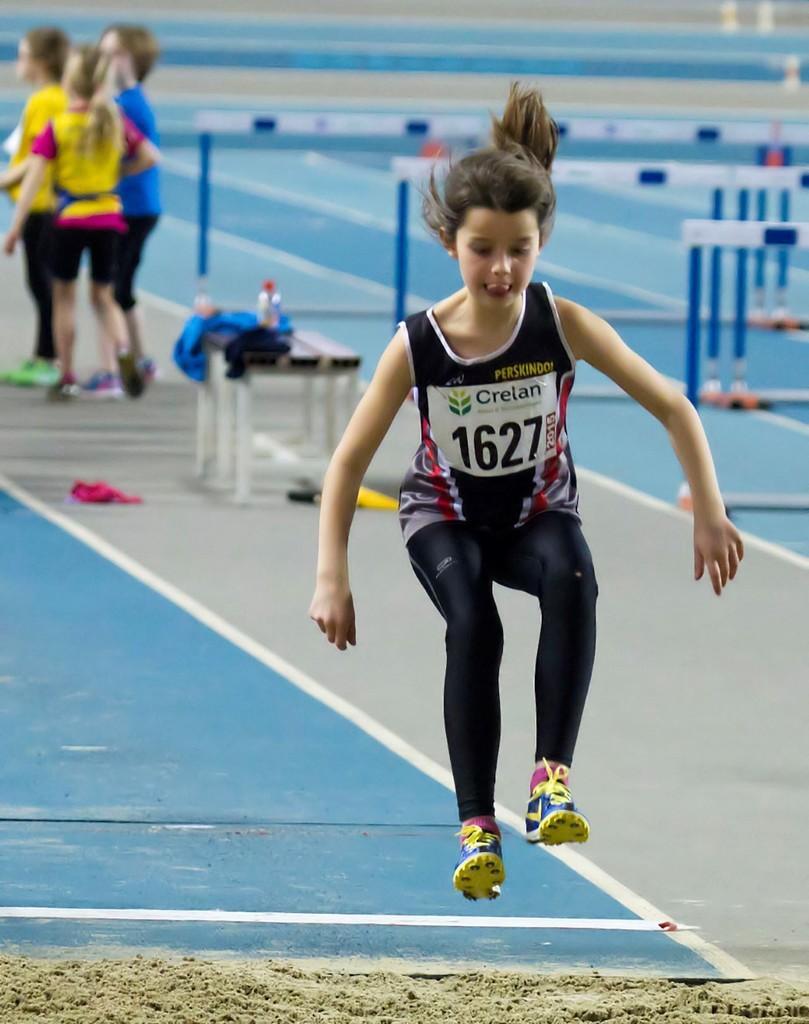Please provide a concise description of this image. In this image we can see a child jumping, in the background there are children standing on the floor, there is a table, on the table there are clothes and bottles and few objects near the table and hurdles on the floor. 